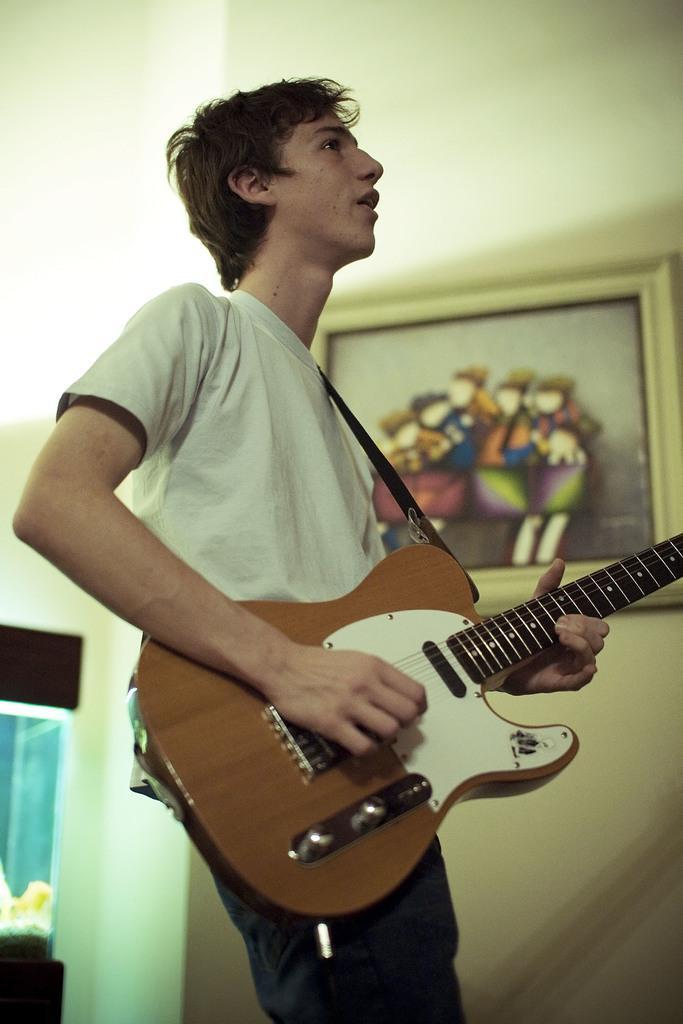Describe this image in one or two sentences. The man in white t-shirt is playing a guitar. A picture on wall. This is an aquarium. 